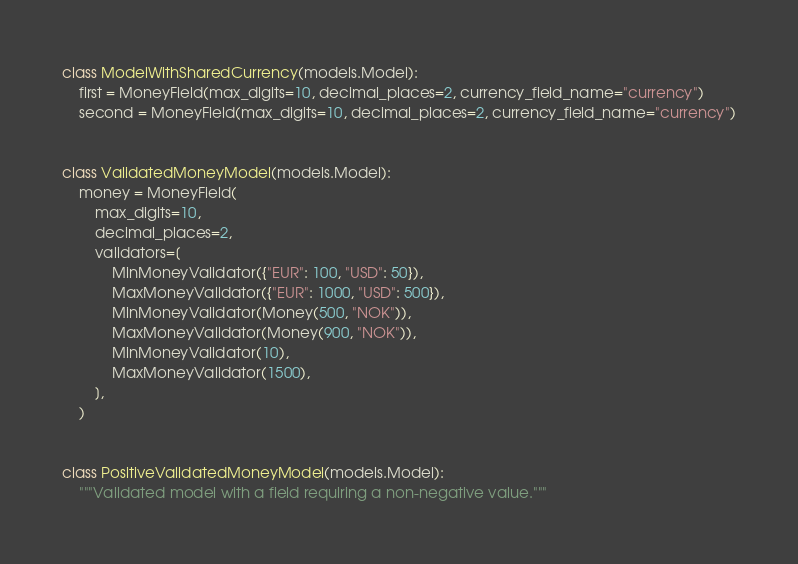Convert code to text. <code><loc_0><loc_0><loc_500><loc_500><_Python_>class ModelWithSharedCurrency(models.Model):
    first = MoneyField(max_digits=10, decimal_places=2, currency_field_name="currency")
    second = MoneyField(max_digits=10, decimal_places=2, currency_field_name="currency")


class ValidatedMoneyModel(models.Model):
    money = MoneyField(
        max_digits=10,
        decimal_places=2,
        validators=[
            MinMoneyValidator({"EUR": 100, "USD": 50}),
            MaxMoneyValidator({"EUR": 1000, "USD": 500}),
            MinMoneyValidator(Money(500, "NOK")),
            MaxMoneyValidator(Money(900, "NOK")),
            MinMoneyValidator(10),
            MaxMoneyValidator(1500),
        ],
    )


class PositiveValidatedMoneyModel(models.Model):
    """Validated model with a field requiring a non-negative value."""
</code> 